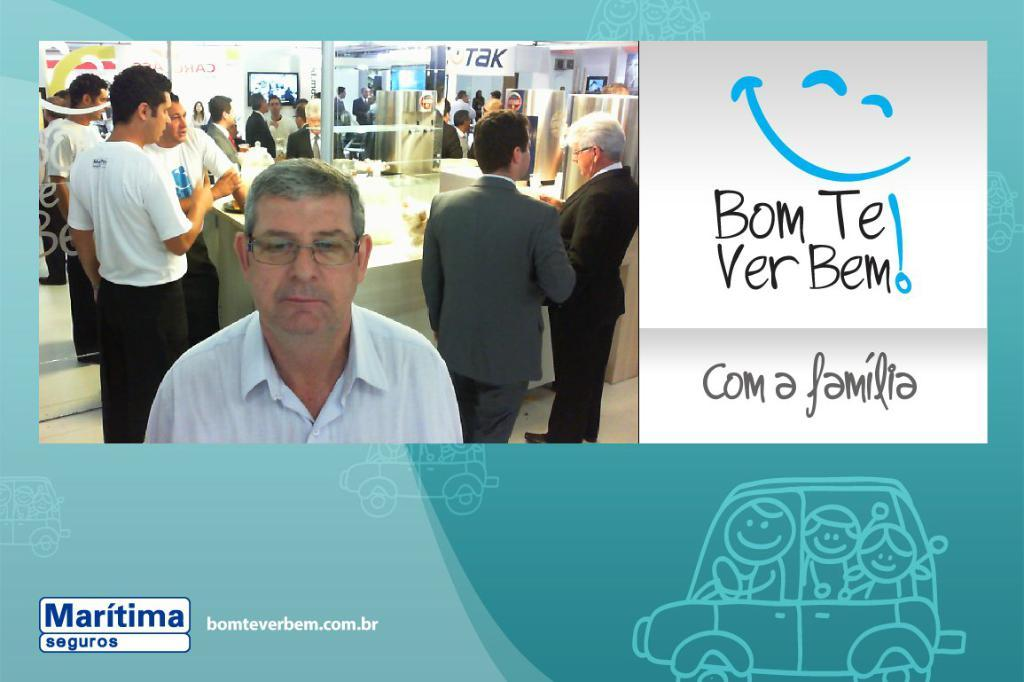What is the main subject of the poster in the image? The poster contains a picture of people. What other elements are present on the poster besides the picture of people? The poster contains screens and other things. Is there any text on the poster? Yes, there is writing on the poster. What type of vegetable is being used as a fan in the image? There is no vegetable or fan present in the image. What kind of joke is depicted on the poster? There is no joke depicted on the poster; it contains a picture of people, screens, other things, and writing. 